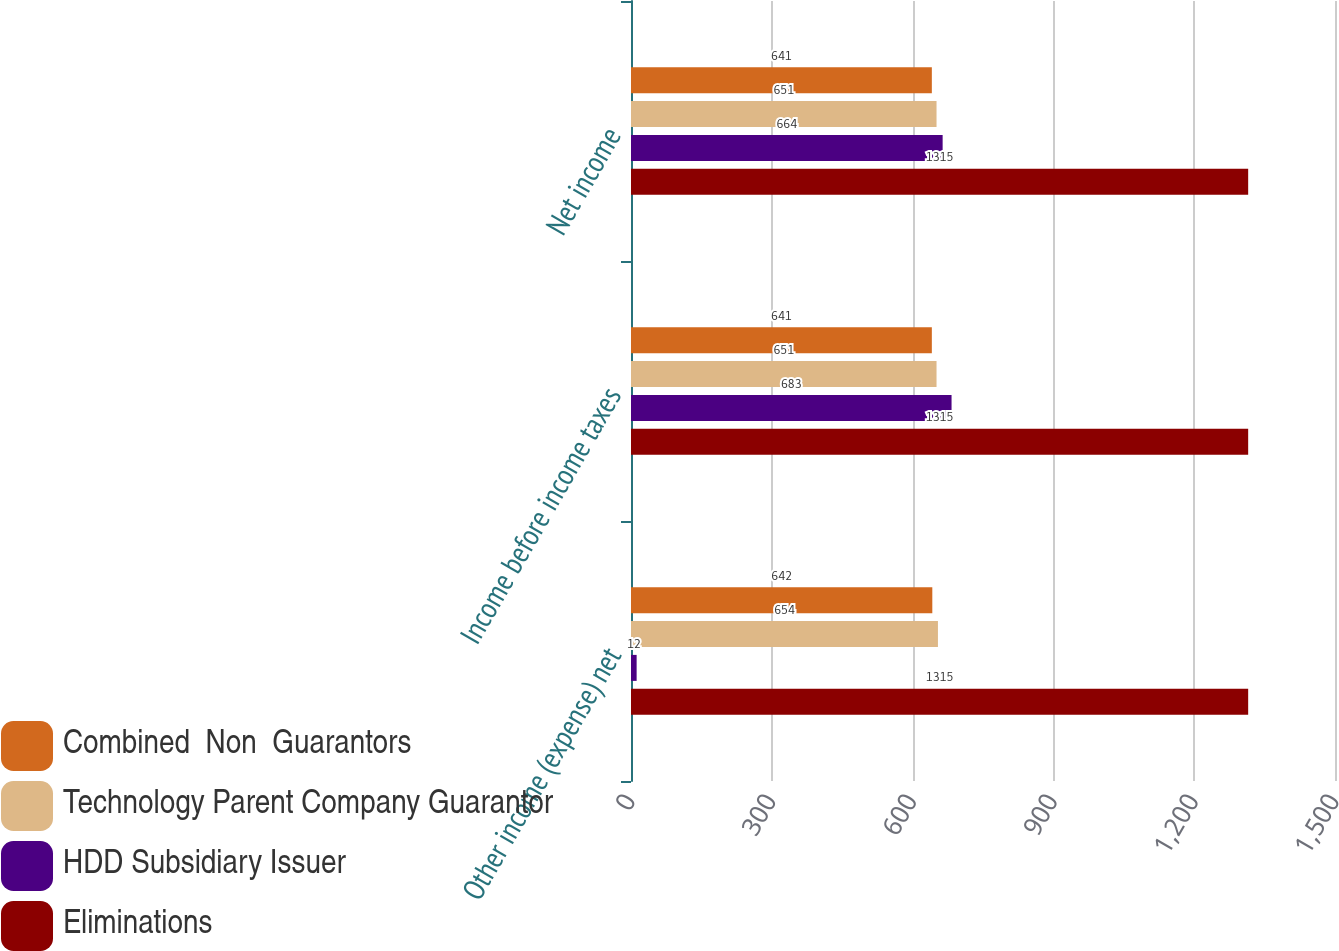Convert chart to OTSL. <chart><loc_0><loc_0><loc_500><loc_500><stacked_bar_chart><ecel><fcel>Other income (expense) net<fcel>Income before income taxes<fcel>Net income<nl><fcel>Combined  Non  Guarantors<fcel>642<fcel>641<fcel>641<nl><fcel>Technology Parent Company Guarantor<fcel>654<fcel>651<fcel>651<nl><fcel>HDD Subsidiary Issuer<fcel>12<fcel>683<fcel>664<nl><fcel>Eliminations<fcel>1315<fcel>1315<fcel>1315<nl></chart> 